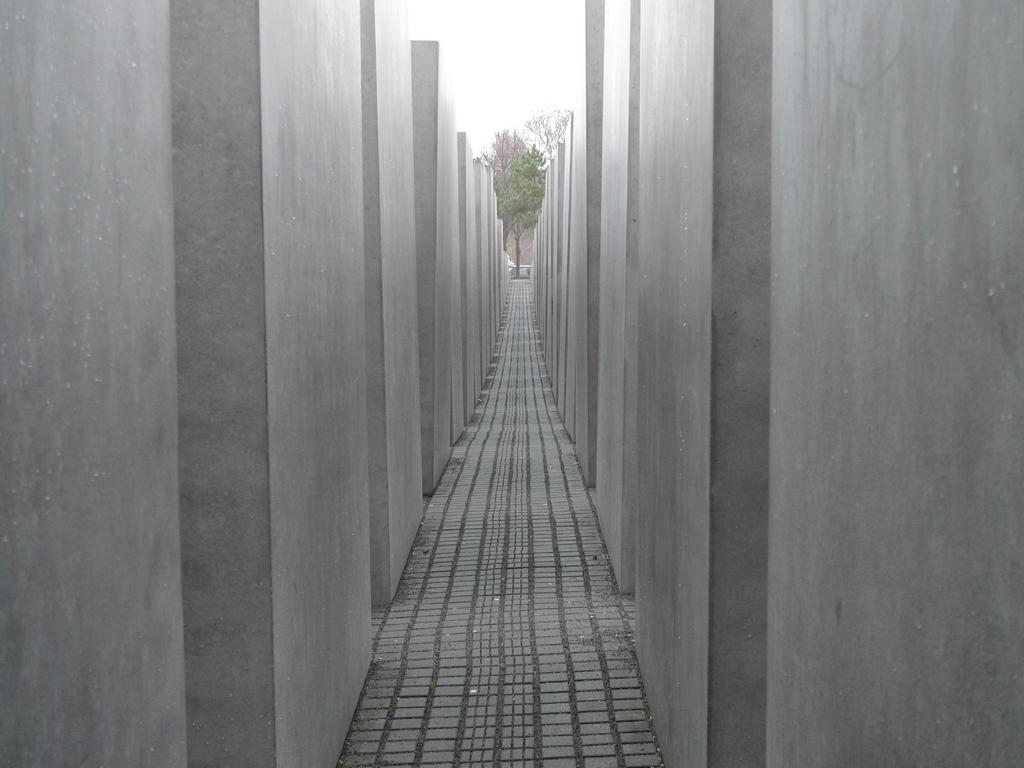What is the main feature of the image? There is a path in the image. What surrounds the path on both sides? There are walls on the left and right sides of the path, resembling pillars. What can be seen in front of the path? There is a tree in front of the path. What is visible at the top of the image? The sky is visible at the top of the image. What type of trade is being conducted in the image? There is no indication of any trade being conducted in the image; it primarily features a path with surrounding walls and a tree. Can you tell me where the nearest hospital is in the image? There is no hospital present in the image; it only shows a path, walls, a tree, and the sky. 